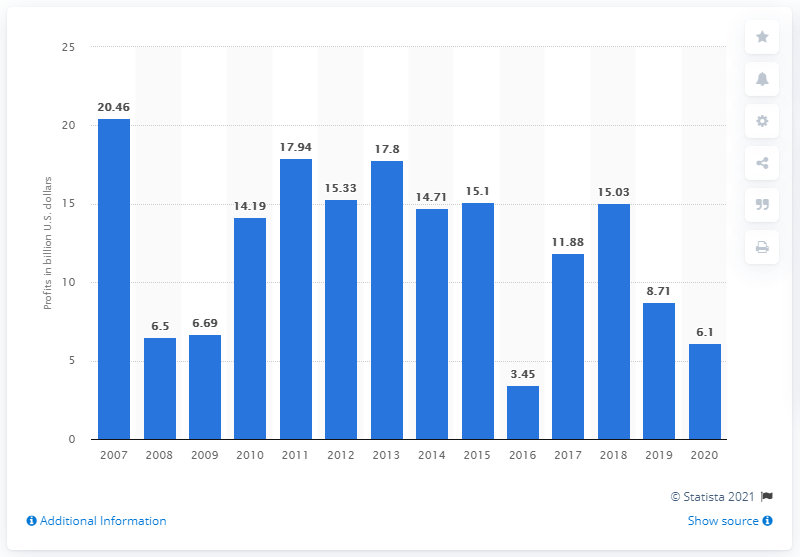List a handful of essential elements in this visual. In 2020, HSBC reported a profit of 6.1 billion dollars. 